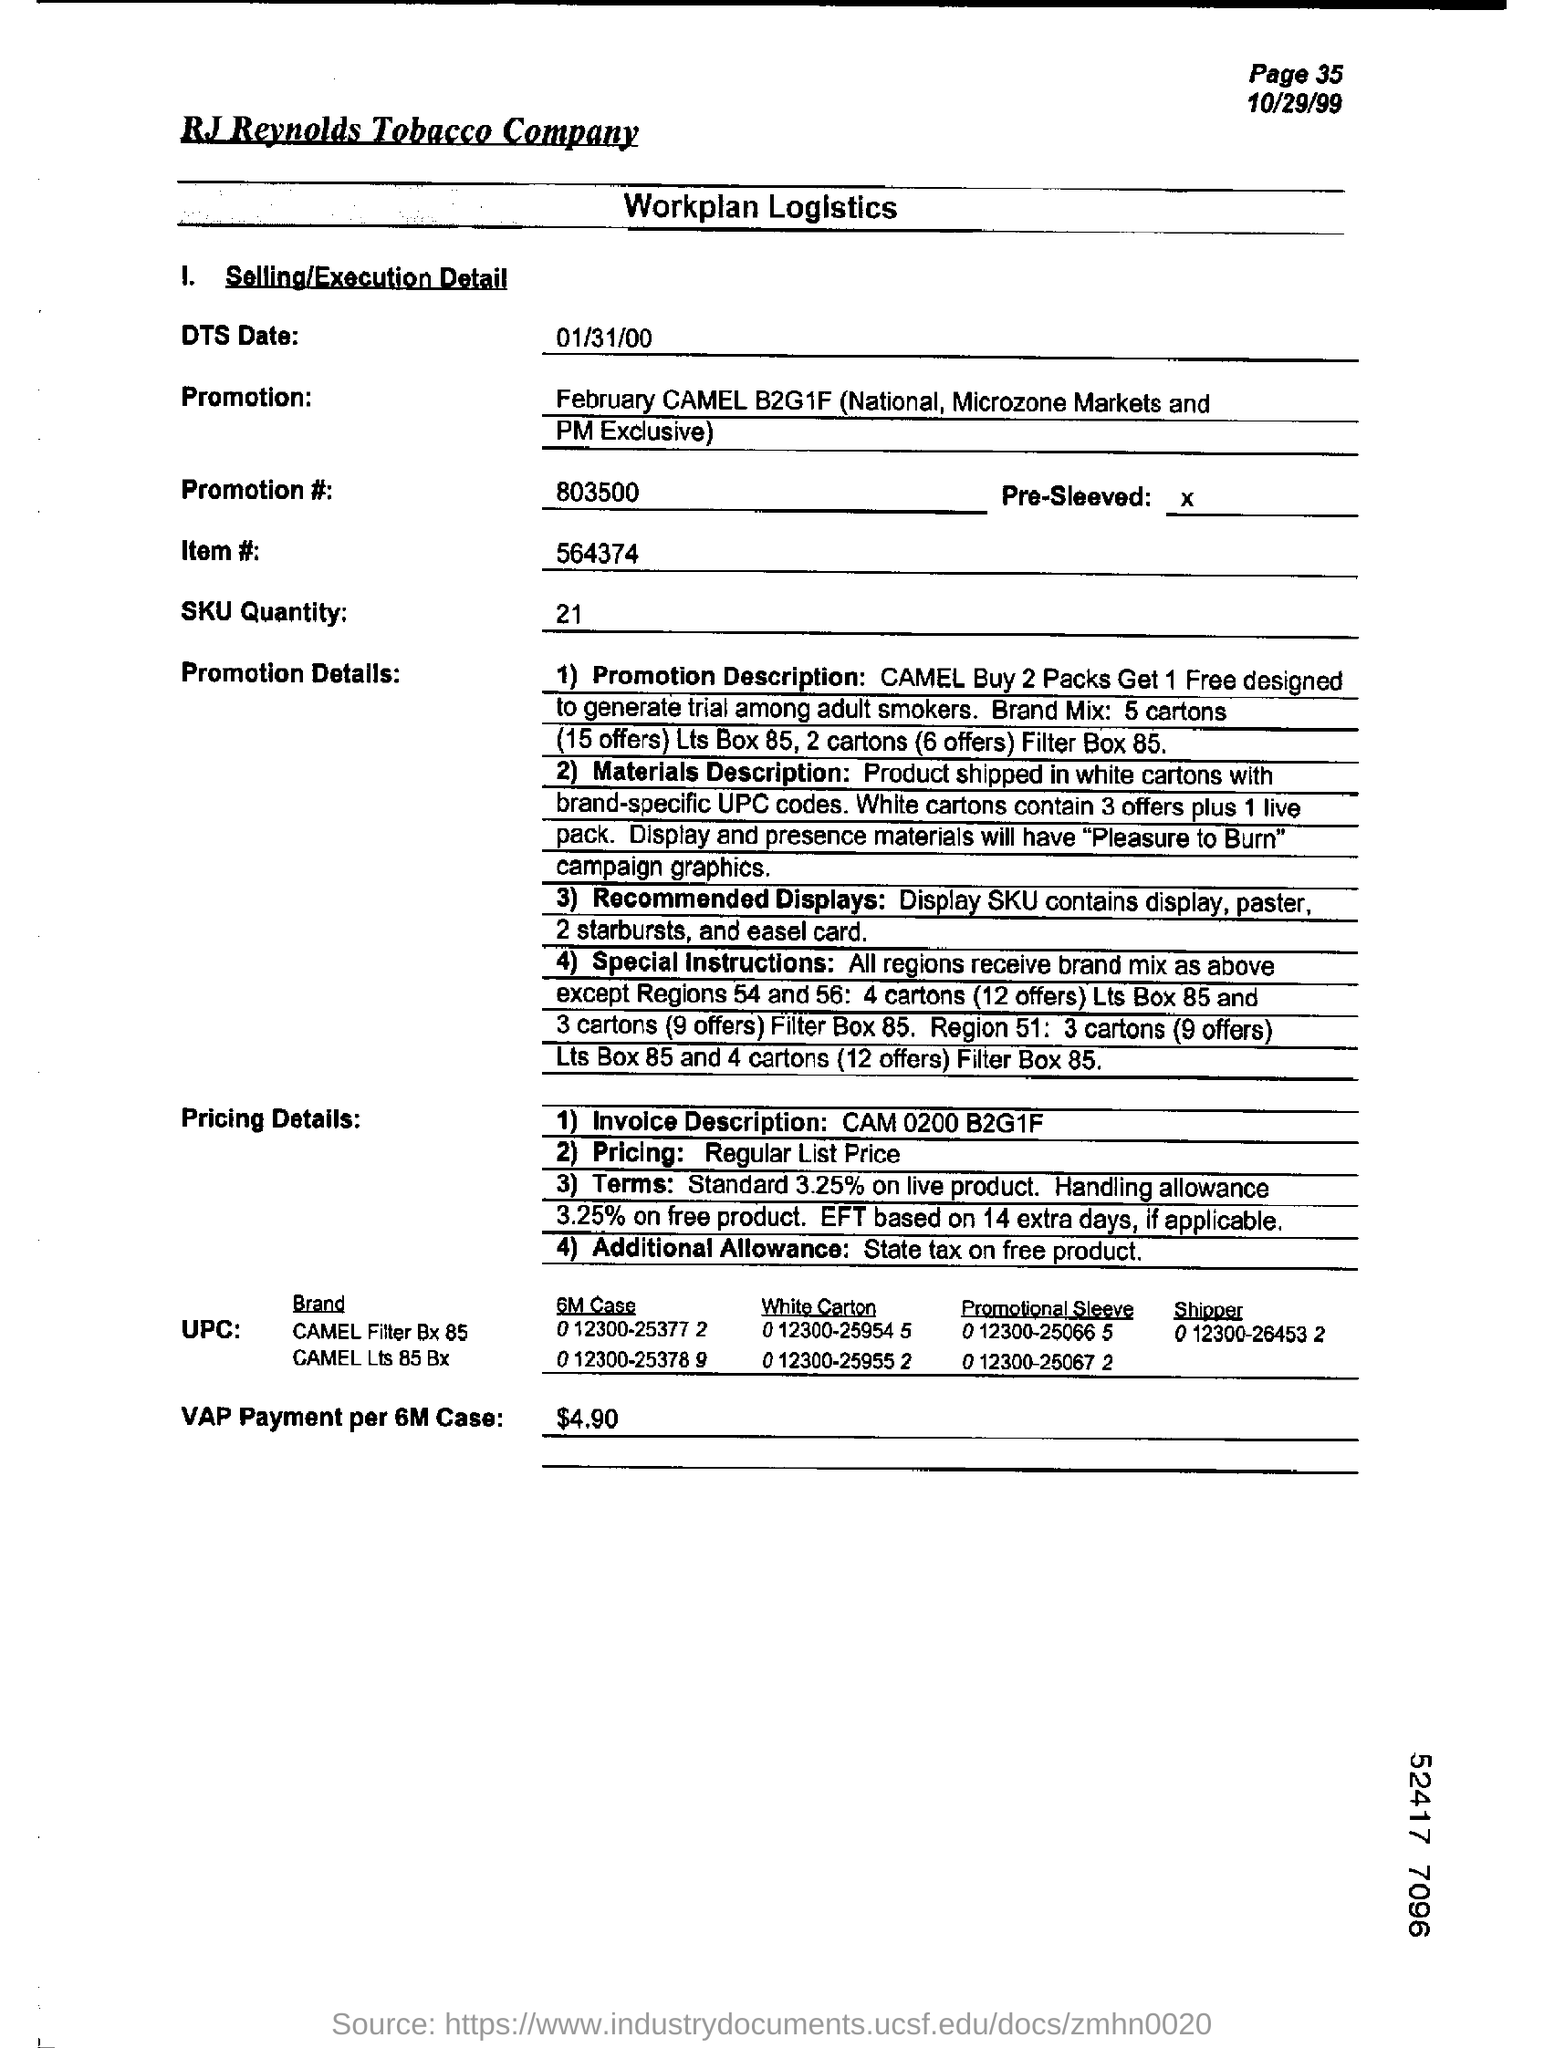What is the DTS Date mentioned in this document?
Keep it short and to the point. 01/31/00. What is SKU Quantity as per the document?
Provide a succinct answer. 21. How much is the VAP Payment per 6M Case?
Keep it short and to the point. $ 4.90. What is the ITEM# as mentioned in the document?
Give a very brief answer. 564374. What is the page no mentioned in this document?
Keep it short and to the point. 35. Which Company's Workplan Logistics is given here?
Provide a short and direct response. RJ Reynolds Tobacco Company. 